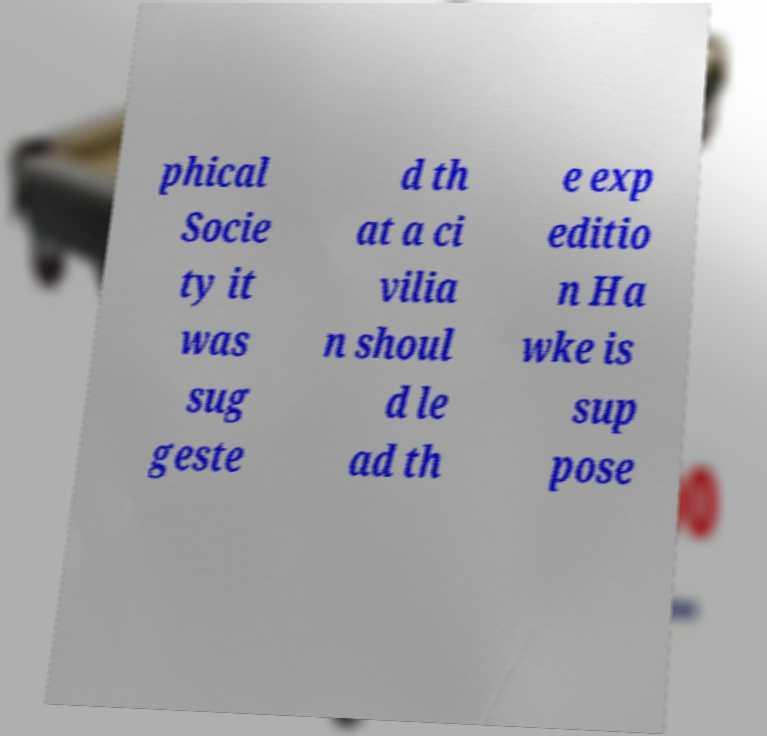For documentation purposes, I need the text within this image transcribed. Could you provide that? phical Socie ty it was sug geste d th at a ci vilia n shoul d le ad th e exp editio n Ha wke is sup pose 